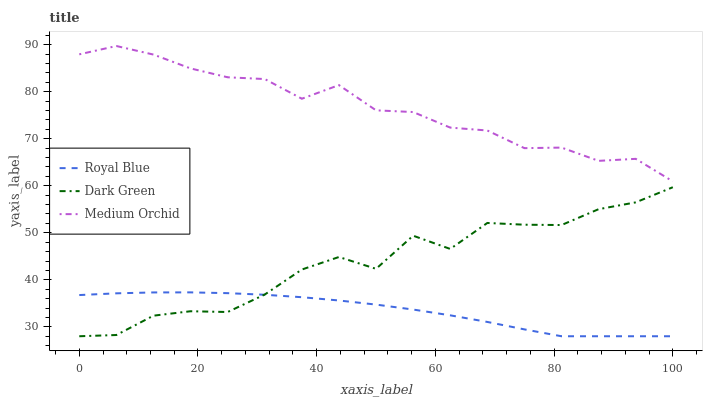Does Royal Blue have the minimum area under the curve?
Answer yes or no. Yes. Does Medium Orchid have the maximum area under the curve?
Answer yes or no. Yes. Does Dark Green have the minimum area under the curve?
Answer yes or no. No. Does Dark Green have the maximum area under the curve?
Answer yes or no. No. Is Royal Blue the smoothest?
Answer yes or no. Yes. Is Dark Green the roughest?
Answer yes or no. Yes. Is Medium Orchid the smoothest?
Answer yes or no. No. Is Medium Orchid the roughest?
Answer yes or no. No. Does Royal Blue have the lowest value?
Answer yes or no. Yes. Does Medium Orchid have the lowest value?
Answer yes or no. No. Does Medium Orchid have the highest value?
Answer yes or no. Yes. Does Dark Green have the highest value?
Answer yes or no. No. Is Royal Blue less than Medium Orchid?
Answer yes or no. Yes. Is Medium Orchid greater than Royal Blue?
Answer yes or no. Yes. Does Dark Green intersect Royal Blue?
Answer yes or no. Yes. Is Dark Green less than Royal Blue?
Answer yes or no. No. Is Dark Green greater than Royal Blue?
Answer yes or no. No. Does Royal Blue intersect Medium Orchid?
Answer yes or no. No. 